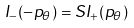<formula> <loc_0><loc_0><loc_500><loc_500>I _ { - } ( - p _ { \theta } ) = S I _ { + } ( p _ { \theta } )</formula> 